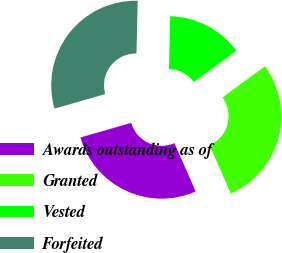Convert chart to OTSL. <chart><loc_0><loc_0><loc_500><loc_500><pie_chart><fcel>Awards outstanding as of<fcel>Granted<fcel>Vested<fcel>Forfeited<nl><fcel>27.12%<fcel>28.47%<fcel>14.58%<fcel>29.82%<nl></chart> 